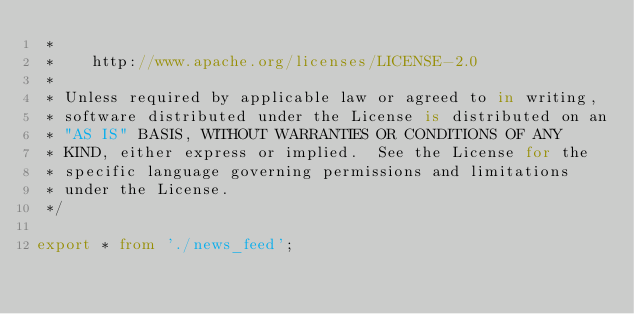<code> <loc_0><loc_0><loc_500><loc_500><_TypeScript_> *
 *    http://www.apache.org/licenses/LICENSE-2.0
 *
 * Unless required by applicable law or agreed to in writing,
 * software distributed under the License is distributed on an
 * "AS IS" BASIS, WITHOUT WARRANTIES OR CONDITIONS OF ANY
 * KIND, either express or implied.  See the License for the
 * specific language governing permissions and limitations
 * under the License.
 */

export * from './news_feed';
</code> 